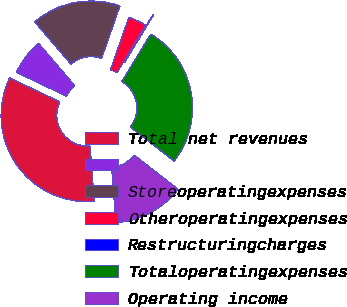<chart> <loc_0><loc_0><loc_500><loc_500><pie_chart><fcel>Total net revenues<fcel>Unnamed: 1<fcel>Storeoperatingexpenses<fcel>Otheroperatingexpenses<fcel>Restructuringcharges<fcel>Totaloperatingexpenses<fcel>Operating income<nl><fcel>33.26%<fcel>6.66%<fcel>16.63%<fcel>3.33%<fcel>0.01%<fcel>26.79%<fcel>13.31%<nl></chart> 